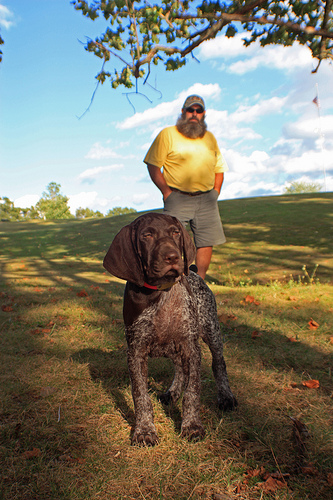Please provide a short description for this region: [0.47, 0.24, 0.64, 0.38]. This is the upper torso of a man wearing a casual T-shirt, possibly in a light color, standing outdoors. 